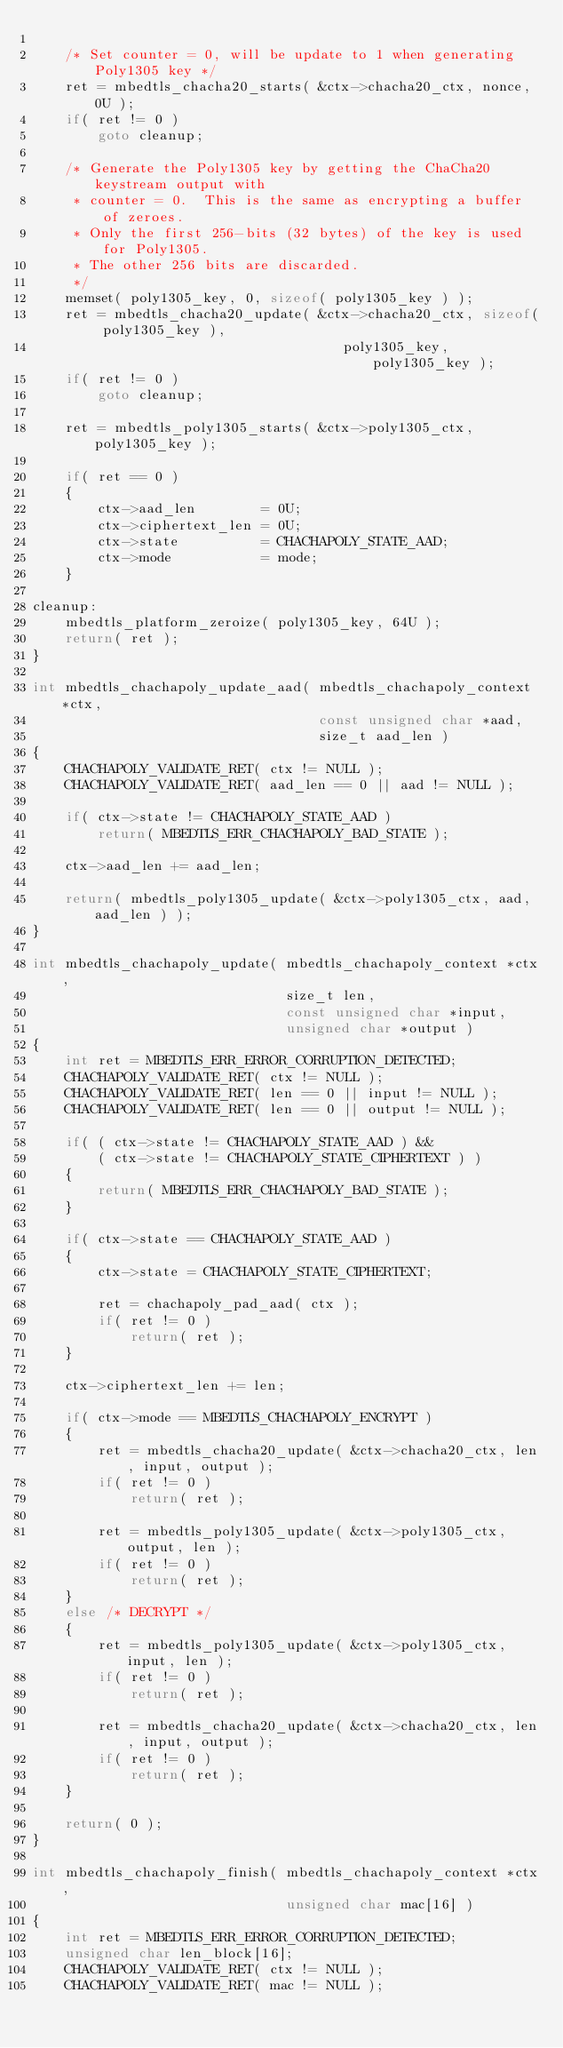Convert code to text. <code><loc_0><loc_0><loc_500><loc_500><_C_>
    /* Set counter = 0, will be update to 1 when generating Poly1305 key */
    ret = mbedtls_chacha20_starts( &ctx->chacha20_ctx, nonce, 0U );
    if( ret != 0 )
        goto cleanup;

    /* Generate the Poly1305 key by getting the ChaCha20 keystream output with
     * counter = 0.  This is the same as encrypting a buffer of zeroes.
     * Only the first 256-bits (32 bytes) of the key is used for Poly1305.
     * The other 256 bits are discarded.
     */
    memset( poly1305_key, 0, sizeof( poly1305_key ) );
    ret = mbedtls_chacha20_update( &ctx->chacha20_ctx, sizeof( poly1305_key ),
                                      poly1305_key, poly1305_key );
    if( ret != 0 )
        goto cleanup;

    ret = mbedtls_poly1305_starts( &ctx->poly1305_ctx, poly1305_key );

    if( ret == 0 )
    {
        ctx->aad_len        = 0U;
        ctx->ciphertext_len = 0U;
        ctx->state          = CHACHAPOLY_STATE_AAD;
        ctx->mode           = mode;
    }

cleanup:
    mbedtls_platform_zeroize( poly1305_key, 64U );
    return( ret );
}

int mbedtls_chachapoly_update_aad( mbedtls_chachapoly_context *ctx,
                                   const unsigned char *aad,
                                   size_t aad_len )
{
    CHACHAPOLY_VALIDATE_RET( ctx != NULL );
    CHACHAPOLY_VALIDATE_RET( aad_len == 0 || aad != NULL );

    if( ctx->state != CHACHAPOLY_STATE_AAD )
        return( MBEDTLS_ERR_CHACHAPOLY_BAD_STATE );

    ctx->aad_len += aad_len;

    return( mbedtls_poly1305_update( &ctx->poly1305_ctx, aad, aad_len ) );
}

int mbedtls_chachapoly_update( mbedtls_chachapoly_context *ctx,
                               size_t len,
                               const unsigned char *input,
                               unsigned char *output )
{
    int ret = MBEDTLS_ERR_ERROR_CORRUPTION_DETECTED;
    CHACHAPOLY_VALIDATE_RET( ctx != NULL );
    CHACHAPOLY_VALIDATE_RET( len == 0 || input != NULL );
    CHACHAPOLY_VALIDATE_RET( len == 0 || output != NULL );

    if( ( ctx->state != CHACHAPOLY_STATE_AAD ) &&
        ( ctx->state != CHACHAPOLY_STATE_CIPHERTEXT ) )
    {
        return( MBEDTLS_ERR_CHACHAPOLY_BAD_STATE );
    }

    if( ctx->state == CHACHAPOLY_STATE_AAD )
    {
        ctx->state = CHACHAPOLY_STATE_CIPHERTEXT;

        ret = chachapoly_pad_aad( ctx );
        if( ret != 0 )
            return( ret );
    }

    ctx->ciphertext_len += len;

    if( ctx->mode == MBEDTLS_CHACHAPOLY_ENCRYPT )
    {
        ret = mbedtls_chacha20_update( &ctx->chacha20_ctx, len, input, output );
        if( ret != 0 )
            return( ret );

        ret = mbedtls_poly1305_update( &ctx->poly1305_ctx, output, len );
        if( ret != 0 )
            return( ret );
    }
    else /* DECRYPT */
    {
        ret = mbedtls_poly1305_update( &ctx->poly1305_ctx, input, len );
        if( ret != 0 )
            return( ret );

        ret = mbedtls_chacha20_update( &ctx->chacha20_ctx, len, input, output );
        if( ret != 0 )
            return( ret );
    }

    return( 0 );
}

int mbedtls_chachapoly_finish( mbedtls_chachapoly_context *ctx,
                               unsigned char mac[16] )
{
    int ret = MBEDTLS_ERR_ERROR_CORRUPTION_DETECTED;
    unsigned char len_block[16];
    CHACHAPOLY_VALIDATE_RET( ctx != NULL );
    CHACHAPOLY_VALIDATE_RET( mac != NULL );
</code> 